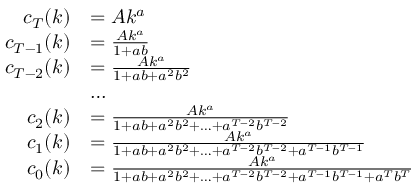Convert formula to latex. <formula><loc_0><loc_0><loc_500><loc_500>{ \begin{array} { r l } { c _ { T } ( k ) } & { = A k ^ { a } } \\ { c _ { T - 1 } ( k ) } & { = { \frac { A k ^ { a } } { 1 + a b } } } \\ { c _ { T - 2 } ( k ) } & { = { \frac { A k ^ { a } } { 1 + a b + a ^ { 2 } b ^ { 2 } } } } \\ & { \dots } \\ { c _ { 2 } ( k ) } & { = { \frac { A k ^ { a } } { 1 + a b + a ^ { 2 } b ^ { 2 } + \dots + a ^ { T - 2 } b ^ { T - 2 } } } } \\ { c _ { 1 } ( k ) } & { = { \frac { A k ^ { a } } { 1 + a b + a ^ { 2 } b ^ { 2 } + \dots + a ^ { T - 2 } b ^ { T - 2 } + a ^ { T - 1 } b ^ { T - 1 } } } } \\ { c _ { 0 } ( k ) } & { = { \frac { A k ^ { a } } { 1 + a b + a ^ { 2 } b ^ { 2 } + \dots + a ^ { T - 2 } b ^ { T - 2 } + a ^ { T - 1 } b ^ { T - 1 } + a ^ { T } b ^ { T } } } } \end{array} }</formula> 